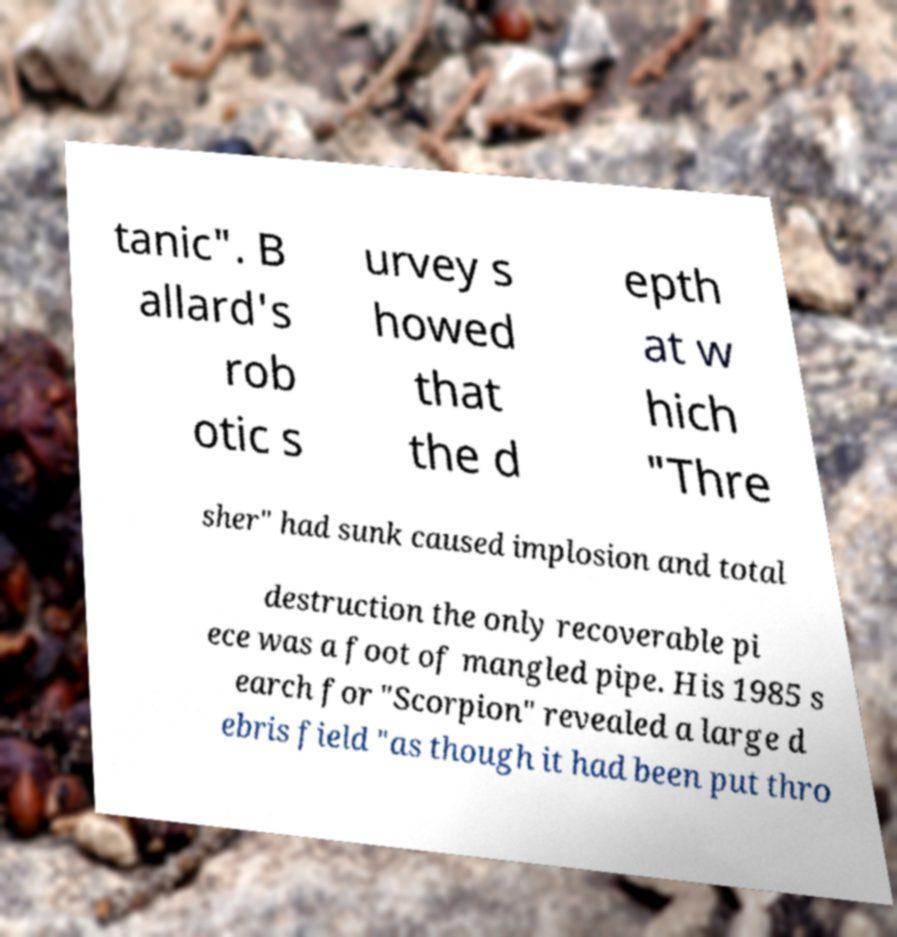I need the written content from this picture converted into text. Can you do that? tanic". B allard's rob otic s urvey s howed that the d epth at w hich "Thre sher" had sunk caused implosion and total destruction the only recoverable pi ece was a foot of mangled pipe. His 1985 s earch for "Scorpion" revealed a large d ebris field "as though it had been put thro 